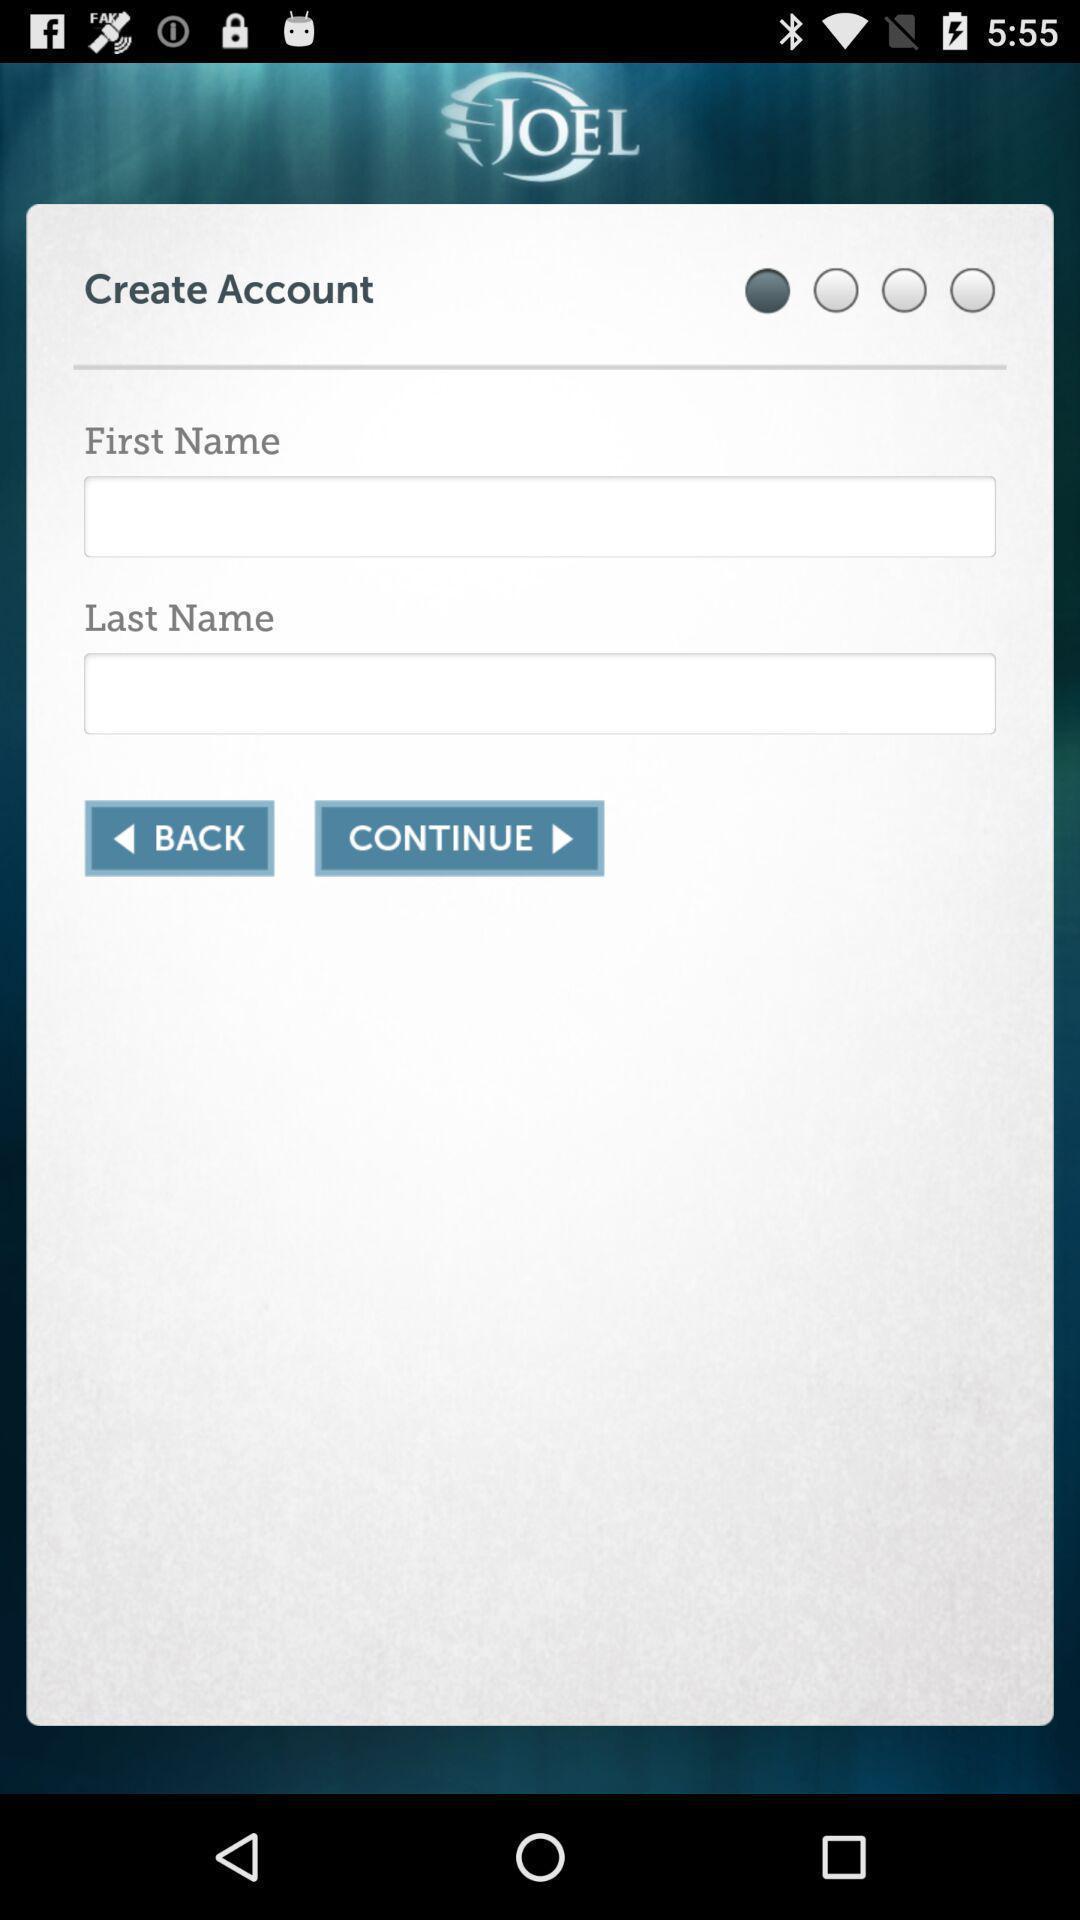What is the overall content of this screenshot? Page displays to create an account in app. 